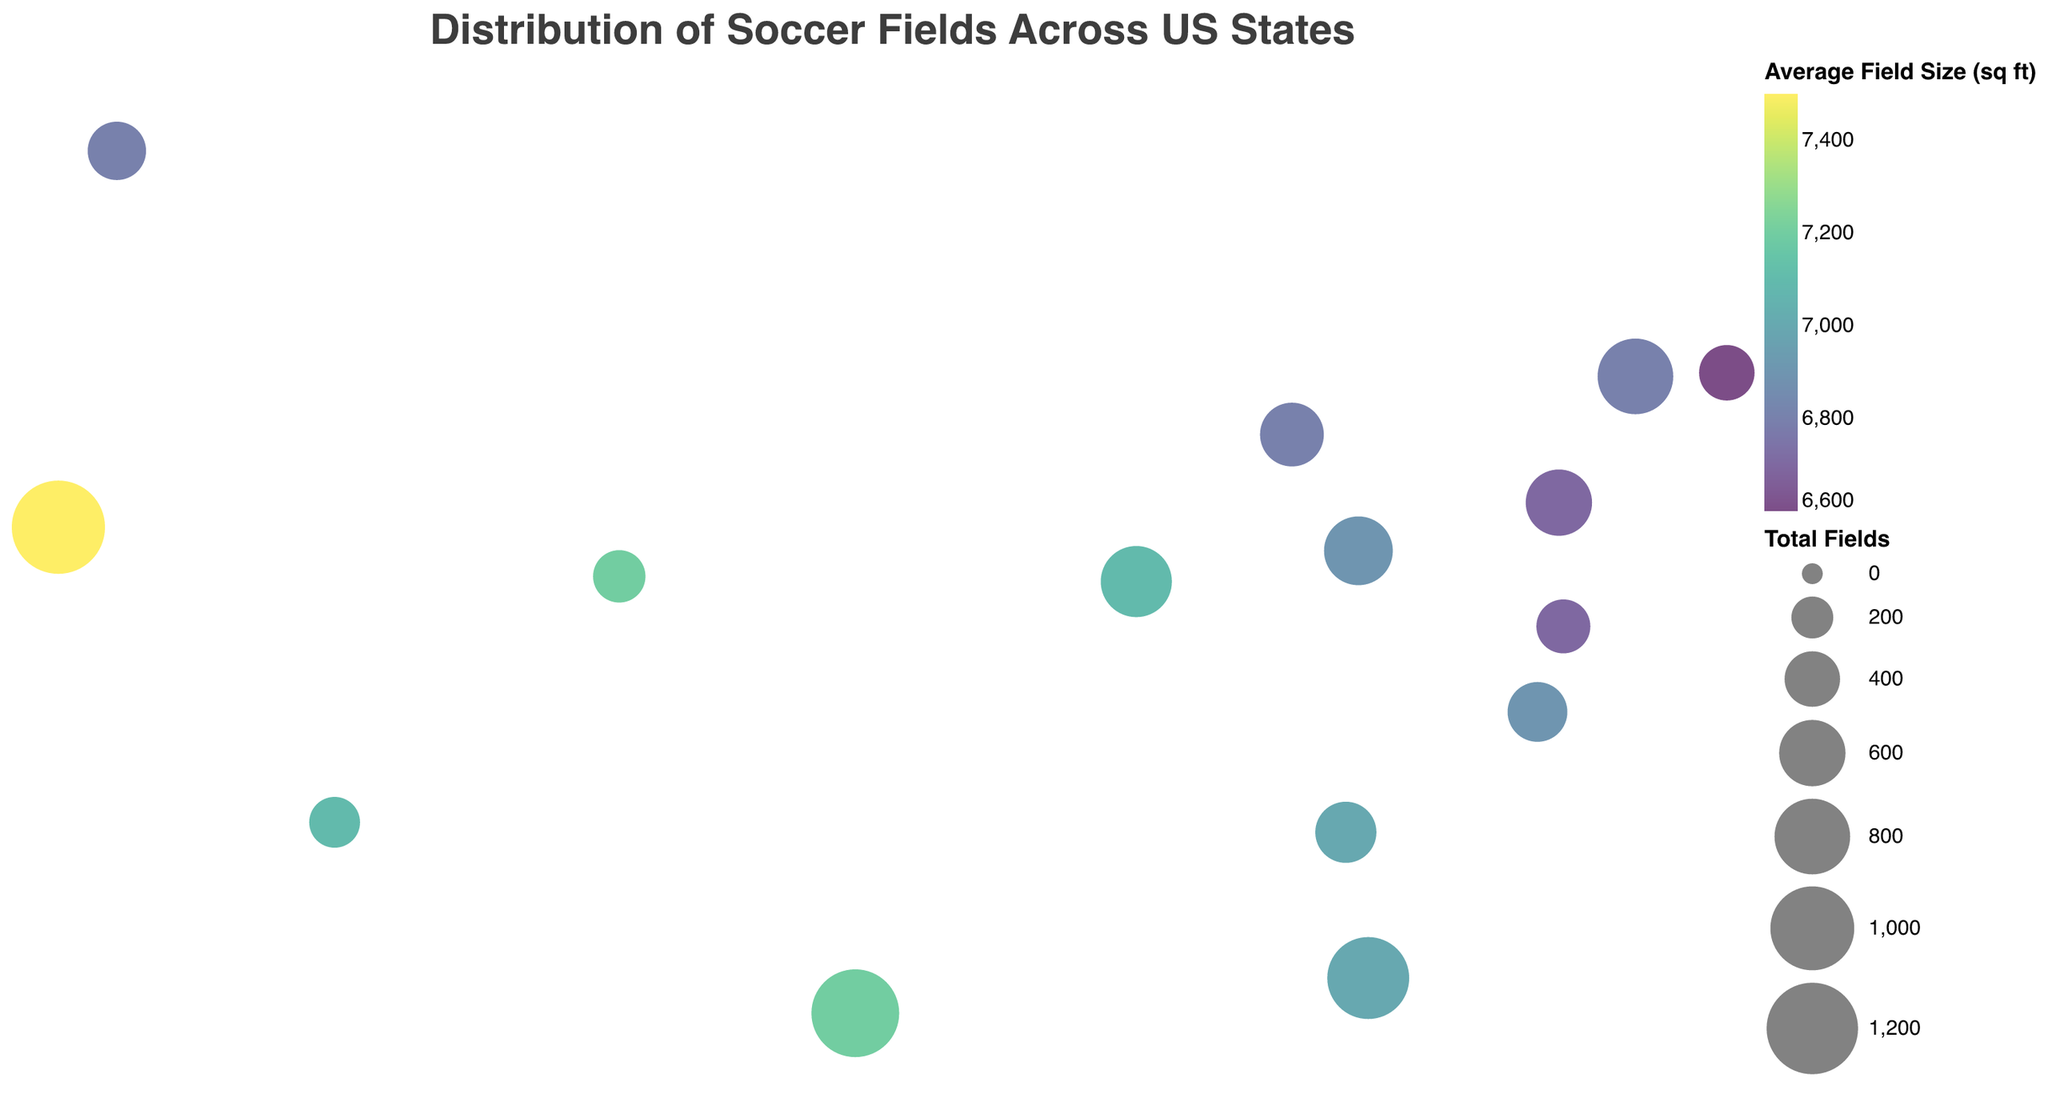Which state has the highest total number of soccer fields? Identify the state with the largest circle, which represents the highest total number of soccer fields. California has the largest circle.
Answer: California Which state has the smallest average field size? Look for the state circle colored with the color corresponding to the smallest value in the average field size color scale. Massachusetts is the state with the darkest color, representing the smallest average field size.
Answer: Massachusetts How many states have more than 500 soccer fields in total? Count the number of circles that are relatively large and check their respective total number of fields from the tooltip. California, Texas, Florida, New York, Illinois, and Ohio have more than 500 soccer fields each.
Answer: 6 Compare the average field sizes between states with the highest and lowest total soccer fields. California has the highest total soccer fields with an average field size of 7500 sq ft. Arizona has the lowest total with an average field size of 7100 sq ft. Compare 7500 and 7100.
Answer: 7500 sq ft in California, 7100 sq ft in Arizona Which state has the highest number of regulation fields? Hover over the circles to reveal the tooltips and identify which state has the highest number of regulation fields. California has the highest number of regulation fields with 750.
Answer: California What is the total number of indoor fields in Texas and Florida combined? Add the number of indoor fields in Texas and Florida. Texas has 75 indoor fields and Florida has 75 indoor fields. Sum 75 + 75.
Answer: 150 Which state has a larger total number of fields: New York or Illinois? Compare the size of circles and verify with the tooltip information for New York and Illinois. New York has 800 total fields, while Illinois has 700 total fields.
Answer: New York How does the number of small-sided fields in Ohio compare to Pennsylvania? Check the tooltips to find the number of small-sided fields for Ohio and Pennsylvania. Ohio has 225 small-sided fields, and Pennsylvania has 200 small-sided fields. Compare 225 with 200.
Answer: Ohio has more Which state has the most balanced distribution of field types? Find the state where the tooltip shows a relatively even number of regulation, small-sided, and indoor fields. No state has an equal distribution, but Colorado seems relatively balanced with 200 regulation fields, 100 small-sided fields, and 50 indoor fields.
Answer: Colorado What is the average field size across all states shown? Sum all the average field sizes and divide by the number of states. (7500 + 7200 + 7000 + 6800 + 7100 + 6900 + 6700 + 6800 + 7000 + 6900 + 6800 + 6600 + 6700 + 7200 + 7100) / 15 = 6973.
Answer: 6973 sq ft 